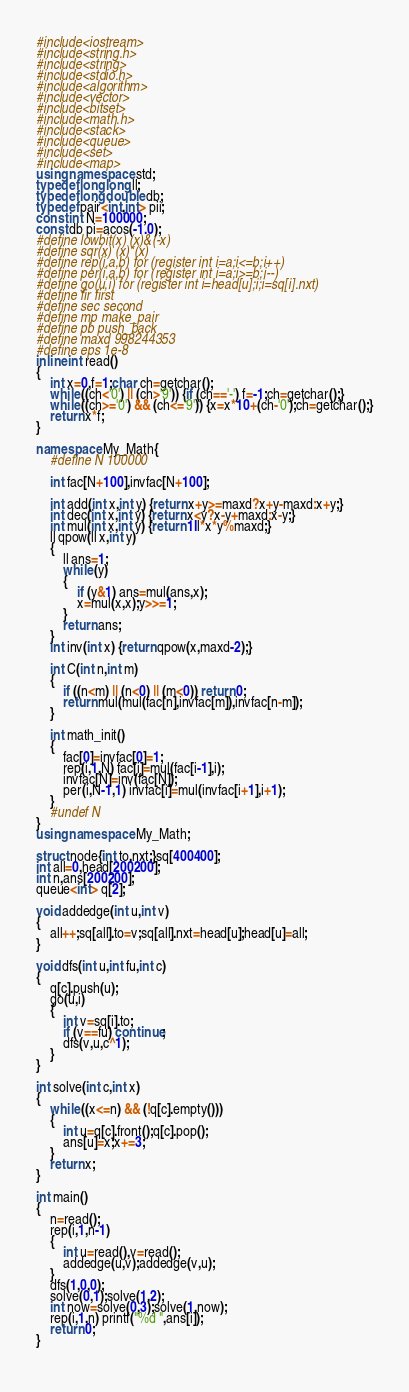<code> <loc_0><loc_0><loc_500><loc_500><_C++_>#include<iostream>
#include<string.h>
#include<string>
#include<stdio.h>
#include<algorithm>
#include<vector>
#include<bitset>
#include<math.h>
#include<stack>
#include<queue>
#include<set>
#include<map>
using namespace std;
typedef long long ll;
typedef long double db;
typedef pair<int,int> pii;
const int N=100000;
const db pi=acos(-1.0);
#define lowbit(x) (x)&(-x)
#define sqr(x) (x)*(x)
#define rep(i,a,b) for (register int i=a;i<=b;i++)
#define per(i,a,b) for (register int i=a;i>=b;i--)
#define go(u,i) for (register int i=head[u];i;i=sq[i].nxt)
#define fir first
#define sec second
#define mp make_pair
#define pb push_back
#define maxd 998244353
#define eps 1e-8
inline int read()
{
    int x=0,f=1;char ch=getchar();
    while ((ch<'0') || (ch>'9')) {if (ch=='-') f=-1;ch=getchar();}
    while ((ch>='0') && (ch<='9')) {x=x*10+(ch-'0');ch=getchar();}
    return x*f;
}

namespace My_Math{
	#define N 100000

	int fac[N+100],invfac[N+100];

	int add(int x,int y) {return x+y>=maxd?x+y-maxd:x+y;}
	int dec(int x,int y) {return x<y?x-y+maxd:x-y;}
	int mul(int x,int y) {return 1ll*x*y%maxd;}
	ll qpow(ll x,int y)
	{
		ll ans=1;
		while (y)
		{
			if (y&1) ans=mul(ans,x);
			x=mul(x,x);y>>=1;
		}
		return ans;
	}
	int inv(int x) {return qpow(x,maxd-2);}

	int C(int n,int m)
	{
		if ((n<m) || (n<0) || (m<0)) return 0;
		return mul(mul(fac[n],invfac[m]),invfac[n-m]);
	}

	int math_init()
	{
		fac[0]=invfac[0]=1;
		rep(i,1,N) fac[i]=mul(fac[i-1],i);
		invfac[N]=inv(fac[N]);
		per(i,N-1,1) invfac[i]=mul(invfac[i+1],i+1);
	}
	#undef N
}
using namespace My_Math;

struct node{int to,nxt;}sq[400400];
int all=0,head[200200];
int n,ans[200200];
queue<int> q[2];

void addedge(int u,int v)
{
	all++;sq[all].to=v;sq[all].nxt=head[u];head[u]=all;
}

void dfs(int u,int fu,int c)
{
	q[c].push(u);
	go(u,i)
	{
		int v=sq[i].to;
		if (v==fu) continue;
		dfs(v,u,c^1);
	}
}

int solve(int c,int x)
{
	while ((x<=n) && (!q[c].empty()))
	{
		int u=q[c].front();q[c].pop();
		ans[u]=x;x+=3;
	}
	return x;
}

int main()
{
	n=read();
	rep(i,1,n-1)
	{
		int u=read(),v=read();
		addedge(u,v);addedge(v,u);
	}
	dfs(1,0,0);
	solve(0,1);solve(1,2);
	int now=solve(0,3);solve(1,now);
	rep(i,1,n) printf("%d ",ans[i]);
	return 0;
}
	

</code> 